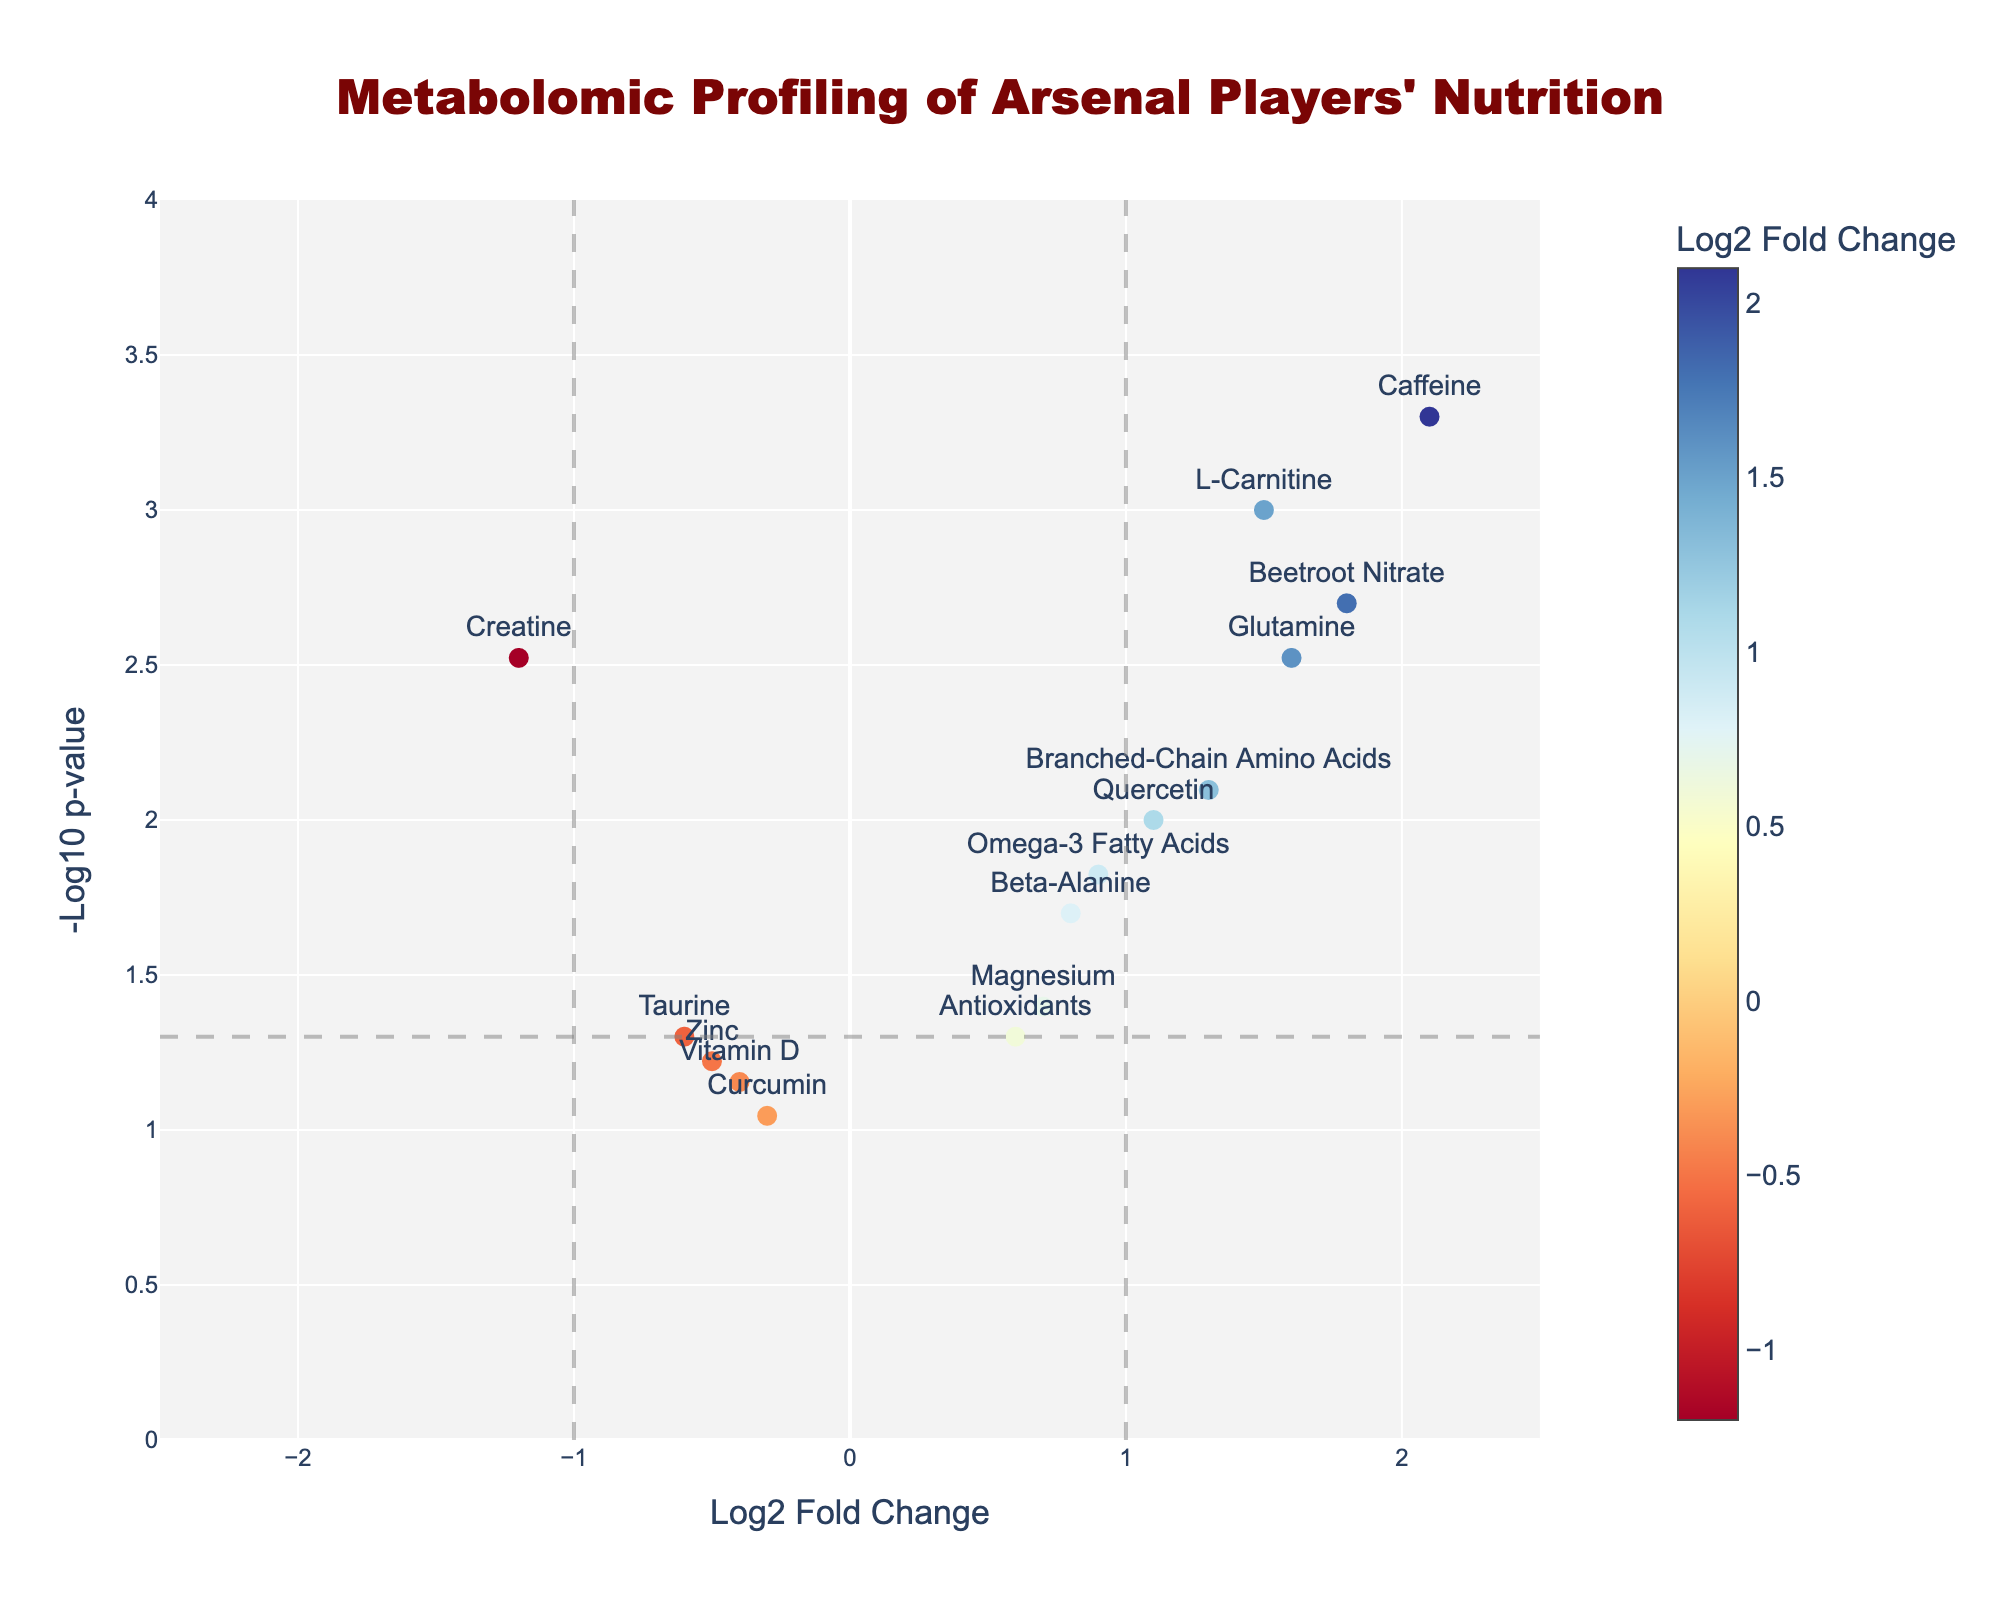What is the title of the plot? The title of the plot is typically displayed at the very top, centered, and is often larger in font size compared to other text elements. In this case, the title is located at the top and reads "Metabolomic Profiling of Arsenal Players' Nutrition".
Answer: Metabolomic Profiling of Arsenal Players' Nutrition What are the axes labels? The axes labels provide context for what the X and Y axes represent. For the X axis, it is labeled "Log2 Fold Change," and for the Y axis, it is labeled "-Log10 p-value".
Answer: X: Log2 Fold Change, Y: -Log10 p-value How many metabolites are shown with significant p-values (p < 0.05)? In the plot, significant p-values are indicated by points above the horizontal grey dashed line, which is at -log10(0.05). The points that fall above this threshold are: Creatine, L-Carnitine, Caffeine, Beetroot Nitrate, Branched-Chain Amino Acids, Quercetin, Glutamine, Omega-3 Fatty Acids, Beta-Alanine. Count these to get the number.
Answer: 9 Which metabolite has the highest Log2 fold change? The metabolite with the largest positive value on the X-axis represents the highest Log2 fold change. This is found by looking at the furthest right data point. In this case, it's Caffeine with a Log2 fold change of 2.1.
Answer: Caffeine What is the median Log2 fold change value? To find the median Log2 fold change, list out all the Log2 fold change values and find the middle value. Arrange: -1.2, -0.6, -0.5, -0.3, -0.4, 0.6, 0.7, 0.8, 0.9, 1.1, 1.3, 1.5, 1.6, 1.8, 2.1. The middle (8th value) is 0.8.
Answer: 0.8 Which nutrients have a negative Log2 fold change and a significant p-value (p < 0.05)? Nutrients that meet both criteria will be to the left of the Y-axis (negative Log2 fold change) and above the grey dashed horizontal line (significant p-value). From the plot, these metabolites are Creatine.
Answer: Creatine Compare Beta-Alanine and Omega-3 Fatty Acids. Which one has a lower p-value? To compare, look at their Y-axis positions. The lower the position, the smaller the -log10 p-value. Omega-3 Fatty Acids is higher on the plot than Beta-Alanine, indicating a lower p-value.
Answer: Omega-3 Fatty Acids How many metabolites show Log2 fold changes greater than 1 and have significant p-values? Look for points that are to the right of the vertical grey dashed line at X=1 and above the horizontal grey dashed line. Metabolites that meet these criteria are L-Carnitine, Caffeine, Beetroot Nitrate, Branched-Chain Amino Acids, and Glutamine.
Answer: 5 Which metabolite has the closest p-value to 0.05 but is still considered significant? The closest significant p-value (just above the threshold line indicated by -log10(0.05)) on the Y-axis will have the smallest height among those just above this line. This is Beta-Alanine with a p-value of exactly 0.02.
Answer: Beta-Alanine 